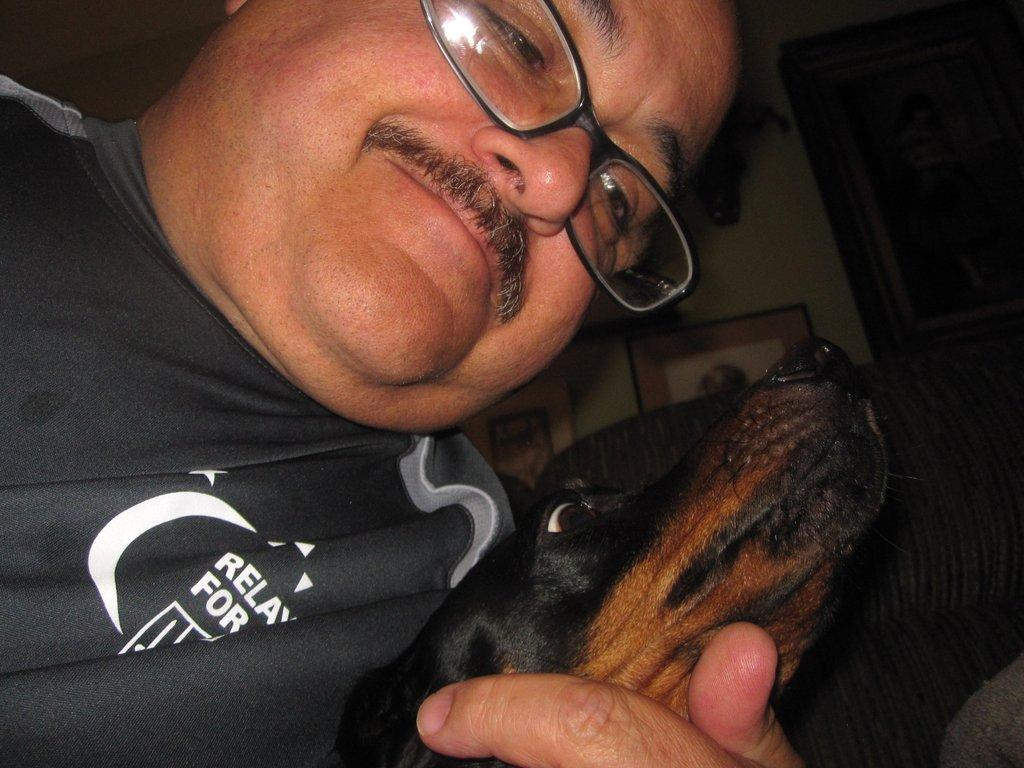Who is present in the image? There is a man in the image. What is the man holding in the image? The man is holding a dog in the image. What can be seen on a chair in the background of the image? There is an object on a chair in the background of the image. What is present on the wall in the background of the image? There are frames and objects on the wall in the background of the image. What type of jelly can be seen on the roof in the image? There is no jelly present on the roof in the image, as the image does not show a roof. 